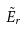Convert formula to latex. <formula><loc_0><loc_0><loc_500><loc_500>\tilde { E } _ { r }</formula> 